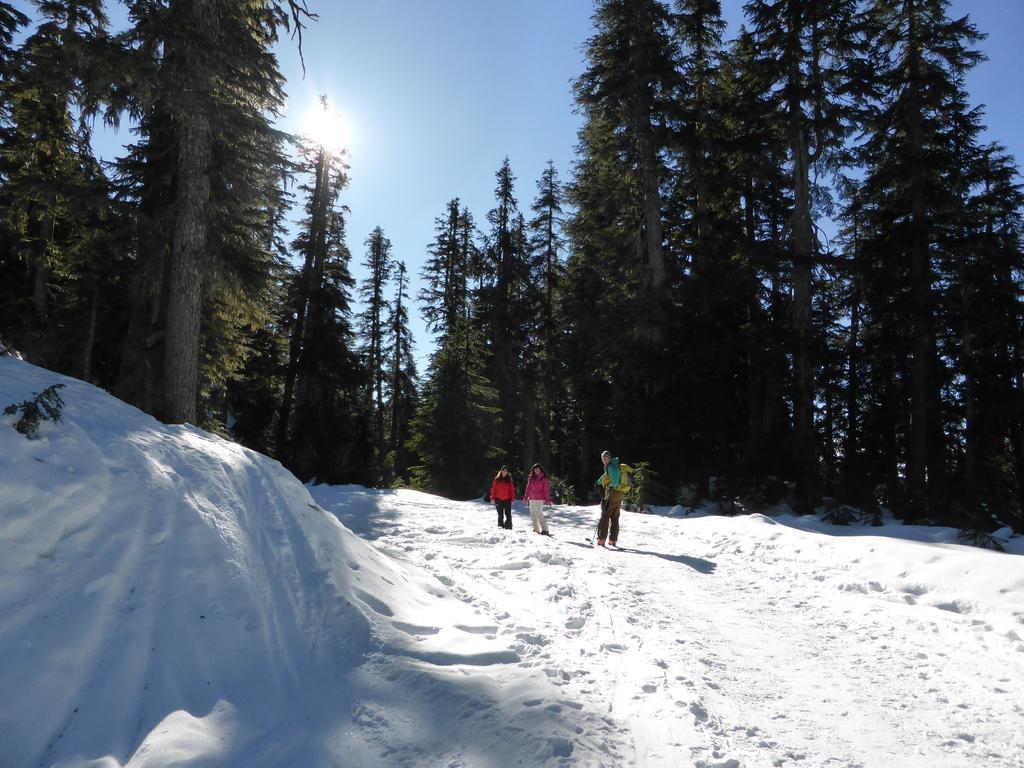Please provide a concise description of this image. In this picture we can see there are three people standing on the snow and behind the people there are trees and the sky. 